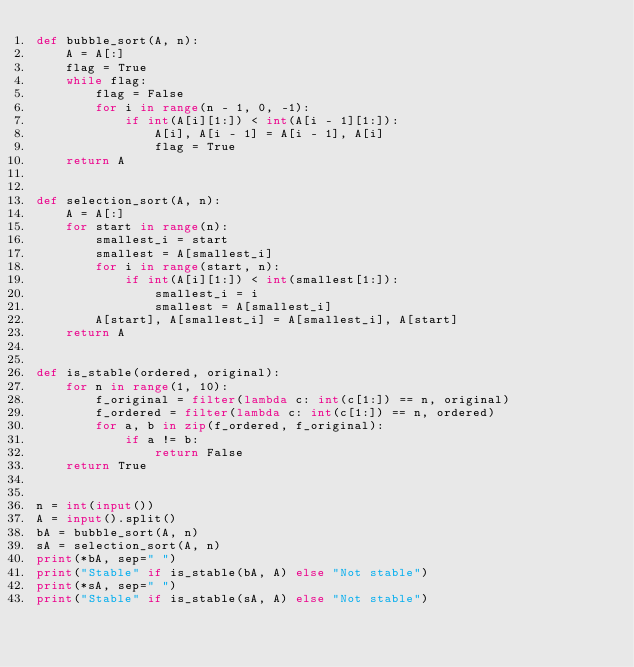<code> <loc_0><loc_0><loc_500><loc_500><_Python_>def bubble_sort(A, n):
    A = A[:]
    flag = True
    while flag:
        flag = False
        for i in range(n - 1, 0, -1):
            if int(A[i][1:]) < int(A[i - 1][1:]):
                A[i], A[i - 1] = A[i - 1], A[i]
                flag = True
    return A


def selection_sort(A, n):
    A = A[:]
    for start in range(n):
        smallest_i = start
        smallest = A[smallest_i]
        for i in range(start, n):
            if int(A[i][1:]) < int(smallest[1:]):
                smallest_i = i
                smallest = A[smallest_i]
        A[start], A[smallest_i] = A[smallest_i], A[start]
    return A


def is_stable(ordered, original):
    for n in range(1, 10):
        f_original = filter(lambda c: int(c[1:]) == n, original)
        f_ordered = filter(lambda c: int(c[1:]) == n, ordered)
        for a, b in zip(f_ordered, f_original):
            if a != b:
                return False
    return True


n = int(input())
A = input().split()
bA = bubble_sort(A, n)
sA = selection_sort(A, n)
print(*bA, sep=" ")
print("Stable" if is_stable(bA, A) else "Not stable")
print(*sA, sep=" ")
print("Stable" if is_stable(sA, A) else "Not stable")

</code> 